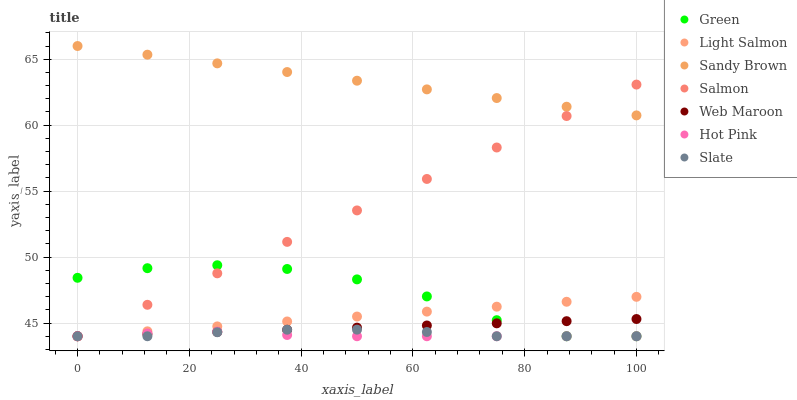Does Hot Pink have the minimum area under the curve?
Answer yes or no. Yes. Does Sandy Brown have the maximum area under the curve?
Answer yes or no. Yes. Does Salmon have the minimum area under the curve?
Answer yes or no. No. Does Salmon have the maximum area under the curve?
Answer yes or no. No. Is Web Maroon the smoothest?
Answer yes or no. Yes. Is Green the roughest?
Answer yes or no. Yes. Is Salmon the smoothest?
Answer yes or no. No. Is Salmon the roughest?
Answer yes or no. No. Does Light Salmon have the lowest value?
Answer yes or no. Yes. Does Sandy Brown have the lowest value?
Answer yes or no. No. Does Sandy Brown have the highest value?
Answer yes or no. Yes. Does Salmon have the highest value?
Answer yes or no. No. Is Green less than Sandy Brown?
Answer yes or no. Yes. Is Sandy Brown greater than Light Salmon?
Answer yes or no. Yes. Does Salmon intersect Light Salmon?
Answer yes or no. Yes. Is Salmon less than Light Salmon?
Answer yes or no. No. Is Salmon greater than Light Salmon?
Answer yes or no. No. Does Green intersect Sandy Brown?
Answer yes or no. No. 